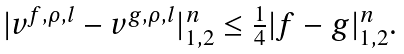Convert formula to latex. <formula><loc_0><loc_0><loc_500><loc_500>\begin{array} { l l } | v ^ { f , \rho , l } - v ^ { g , \rho , l } | ^ { n } _ { 1 , 2 } \leq \frac { 1 } { 4 } | f - g | ^ { n } _ { 1 , 2 } . \end{array}</formula> 